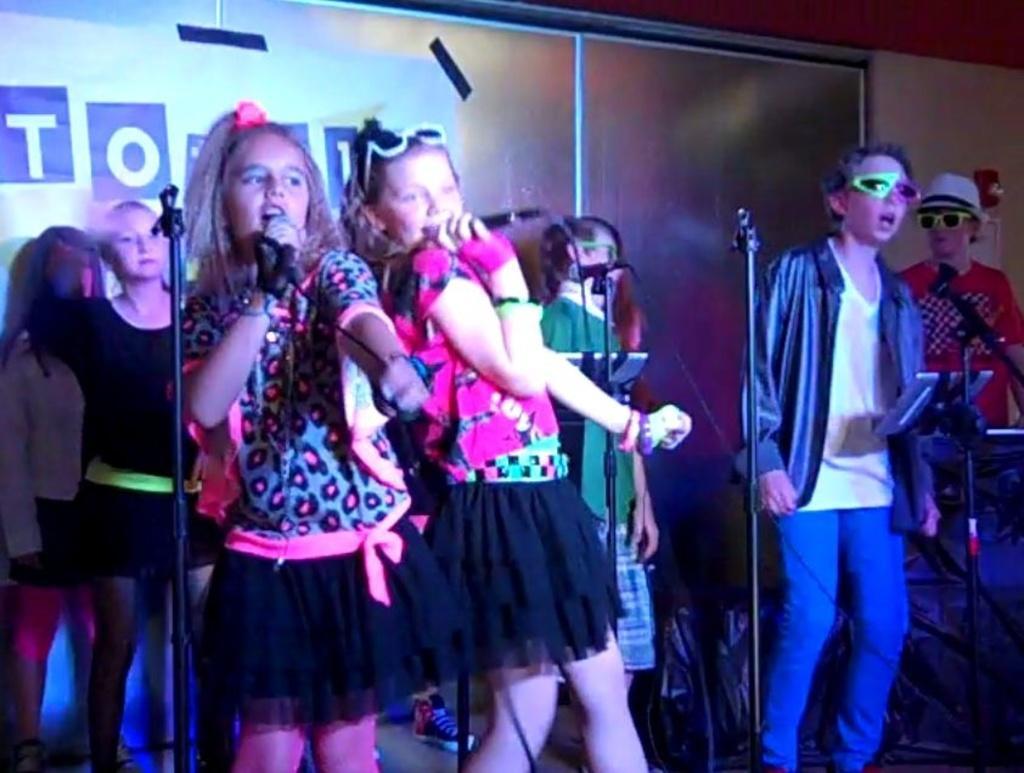Please provide a concise description of this image. This image is taken indoors. In the background there is a wall and there is a banner with a text on it. In the middle of the image a few girls are standing on the dais and singing. They are holding mics in their hands and there are a few mics. On the right side of the image two boys are standing on the dais and they are singing. 